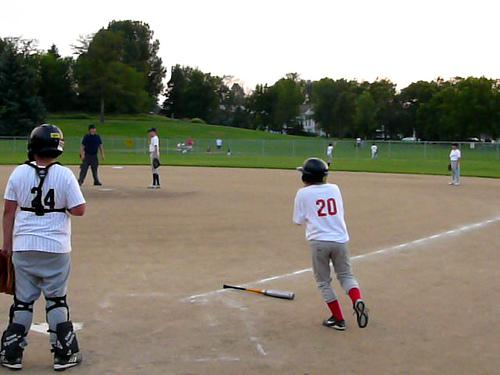Question: who is wearing black?
Choices:
A. Manager.
B. Coach.
C. Player.
D. Umpire.
Answer with the letter. Answer: B Question: what color is the turf?
Choices:
A. Green.
B. Brown.
C. Blue.
D. Yellow.
Answer with the letter. Answer: A Question: where is this picture taken?
Choices:
A. Soccer field.
B. Football field.
C. Baseball field.
D. Golf course.
Answer with the letter. Answer: C Question: what color are their uniforms?
Choices:
A. Blue.
B. White.
C. Brown.
D. Red.
Answer with the letter. Answer: B Question: how many players are on the field?
Choices:
A. 2.
B. 3.
C. 6.
D. 4.
Answer with the letter. Answer: C 